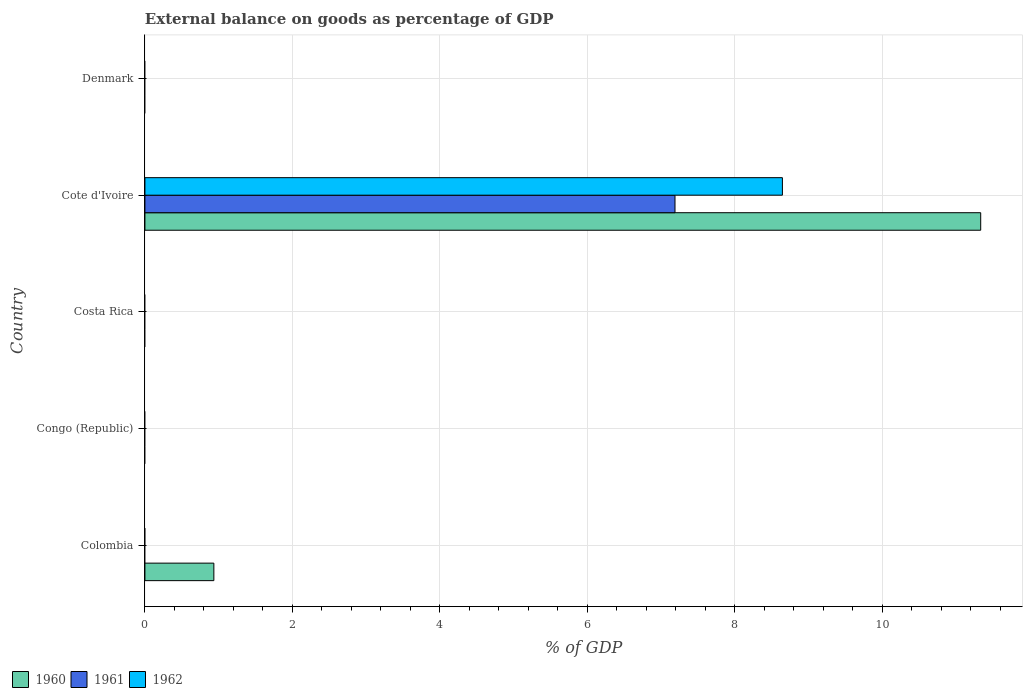How many different coloured bars are there?
Provide a succinct answer. 3. Are the number of bars per tick equal to the number of legend labels?
Provide a succinct answer. No. Are the number of bars on each tick of the Y-axis equal?
Your answer should be very brief. No. How many bars are there on the 2nd tick from the bottom?
Your response must be concise. 0. In how many cases, is the number of bars for a given country not equal to the number of legend labels?
Provide a short and direct response. 4. Across all countries, what is the maximum external balance on goods as percentage of GDP in 1961?
Give a very brief answer. 7.19. In which country was the external balance on goods as percentage of GDP in 1962 maximum?
Offer a very short reply. Cote d'Ivoire. What is the total external balance on goods as percentage of GDP in 1961 in the graph?
Your answer should be compact. 7.19. What is the difference between the external balance on goods as percentage of GDP in 1962 in Congo (Republic) and the external balance on goods as percentage of GDP in 1961 in Colombia?
Make the answer very short. 0. What is the average external balance on goods as percentage of GDP in 1960 per country?
Ensure brevity in your answer.  2.45. What is the difference between the external balance on goods as percentage of GDP in 1960 and external balance on goods as percentage of GDP in 1961 in Cote d'Ivoire?
Provide a succinct answer. 4.15. In how many countries, is the external balance on goods as percentage of GDP in 1961 greater than 10.4 %?
Your answer should be compact. 0. What is the difference between the highest and the lowest external balance on goods as percentage of GDP in 1962?
Provide a short and direct response. 8.65. In how many countries, is the external balance on goods as percentage of GDP in 1961 greater than the average external balance on goods as percentage of GDP in 1961 taken over all countries?
Keep it short and to the point. 1. Is it the case that in every country, the sum of the external balance on goods as percentage of GDP in 1960 and external balance on goods as percentage of GDP in 1962 is greater than the external balance on goods as percentage of GDP in 1961?
Give a very brief answer. No. Are all the bars in the graph horizontal?
Offer a very short reply. Yes. How many countries are there in the graph?
Provide a succinct answer. 5. What is the difference between two consecutive major ticks on the X-axis?
Provide a short and direct response. 2. Are the values on the major ticks of X-axis written in scientific E-notation?
Ensure brevity in your answer.  No. Does the graph contain any zero values?
Your answer should be compact. Yes. Where does the legend appear in the graph?
Your response must be concise. Bottom left. How are the legend labels stacked?
Ensure brevity in your answer.  Horizontal. What is the title of the graph?
Make the answer very short. External balance on goods as percentage of GDP. Does "1970" appear as one of the legend labels in the graph?
Make the answer very short. No. What is the label or title of the X-axis?
Make the answer very short. % of GDP. What is the % of GDP of 1960 in Colombia?
Provide a succinct answer. 0.93. What is the % of GDP of 1961 in Colombia?
Ensure brevity in your answer.  0. What is the % of GDP of 1961 in Costa Rica?
Your answer should be very brief. 0. What is the % of GDP of 1962 in Costa Rica?
Make the answer very short. 0. What is the % of GDP of 1960 in Cote d'Ivoire?
Provide a short and direct response. 11.34. What is the % of GDP in 1961 in Cote d'Ivoire?
Your response must be concise. 7.19. What is the % of GDP in 1962 in Cote d'Ivoire?
Your answer should be very brief. 8.65. What is the % of GDP of 1960 in Denmark?
Provide a succinct answer. 0. What is the % of GDP of 1962 in Denmark?
Your response must be concise. 0. Across all countries, what is the maximum % of GDP of 1960?
Your response must be concise. 11.34. Across all countries, what is the maximum % of GDP in 1961?
Ensure brevity in your answer.  7.19. Across all countries, what is the maximum % of GDP of 1962?
Your response must be concise. 8.65. Across all countries, what is the minimum % of GDP in 1960?
Ensure brevity in your answer.  0. Across all countries, what is the minimum % of GDP in 1961?
Provide a short and direct response. 0. What is the total % of GDP of 1960 in the graph?
Your answer should be compact. 12.27. What is the total % of GDP in 1961 in the graph?
Offer a terse response. 7.19. What is the total % of GDP of 1962 in the graph?
Ensure brevity in your answer.  8.65. What is the difference between the % of GDP of 1960 in Colombia and that in Cote d'Ivoire?
Provide a succinct answer. -10.4. What is the difference between the % of GDP in 1960 in Colombia and the % of GDP in 1961 in Cote d'Ivoire?
Your answer should be very brief. -6.25. What is the difference between the % of GDP in 1960 in Colombia and the % of GDP in 1962 in Cote d'Ivoire?
Ensure brevity in your answer.  -7.71. What is the average % of GDP of 1960 per country?
Make the answer very short. 2.45. What is the average % of GDP in 1961 per country?
Provide a succinct answer. 1.44. What is the average % of GDP in 1962 per country?
Give a very brief answer. 1.73. What is the difference between the % of GDP of 1960 and % of GDP of 1961 in Cote d'Ivoire?
Your answer should be very brief. 4.15. What is the difference between the % of GDP of 1960 and % of GDP of 1962 in Cote d'Ivoire?
Make the answer very short. 2.69. What is the difference between the % of GDP of 1961 and % of GDP of 1962 in Cote d'Ivoire?
Give a very brief answer. -1.46. What is the ratio of the % of GDP of 1960 in Colombia to that in Cote d'Ivoire?
Give a very brief answer. 0.08. What is the difference between the highest and the lowest % of GDP of 1960?
Offer a very short reply. 11.34. What is the difference between the highest and the lowest % of GDP in 1961?
Make the answer very short. 7.19. What is the difference between the highest and the lowest % of GDP of 1962?
Your response must be concise. 8.65. 